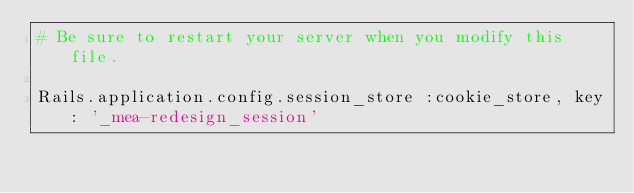<code> <loc_0><loc_0><loc_500><loc_500><_Ruby_># Be sure to restart your server when you modify this file.

Rails.application.config.session_store :cookie_store, key: '_mea-redesign_session'
</code> 